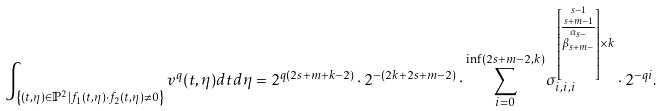<formula> <loc_0><loc_0><loc_500><loc_500>\int _ { \left \{ ( t , \eta ) \in \mathbb { P } ^ { 2 } | f _ { 1 } ( t , \eta ) \cdot f _ { 2 } ( t , \eta ) \neq 0 \right \} } v ^ { q } ( t , \eta ) d t d \eta = 2 ^ { q ( 2 s + m + k - 2 ) } \cdot 2 ^ { - ( 2 k + 2 s + m - 2 ) } \cdot \sum _ { i = 0 } ^ { \inf ( 2 s + m - 2 , k ) } \sigma _ { i , i , i } ^ { \left [ \stackrel { s - 1 } { \stackrel { s + m - 1 } { \overline { \stackrel { \alpha _ { s - } } { \beta _ { s + m - } } } } } \right ] \times k } \cdot 2 ^ { - q i } .</formula> 